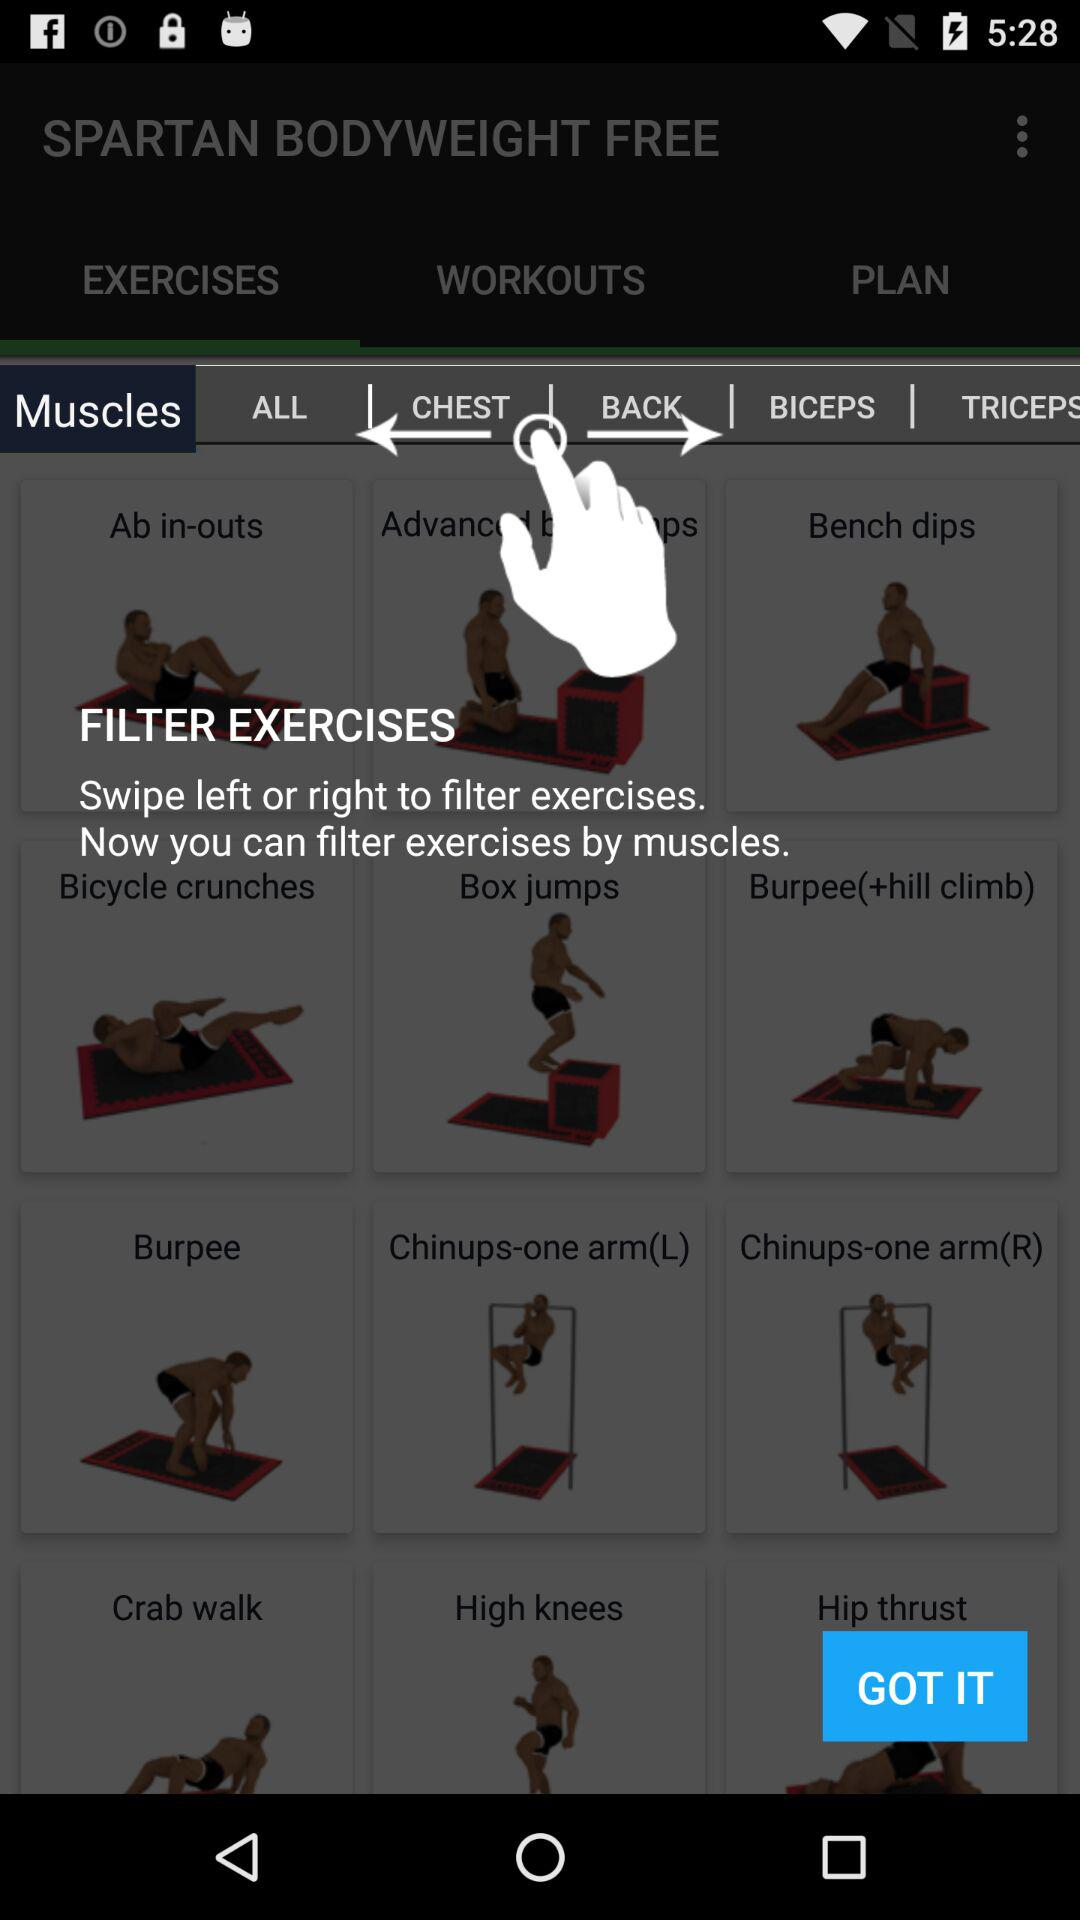What is the selected tab? The selected tab is "Muscles". 